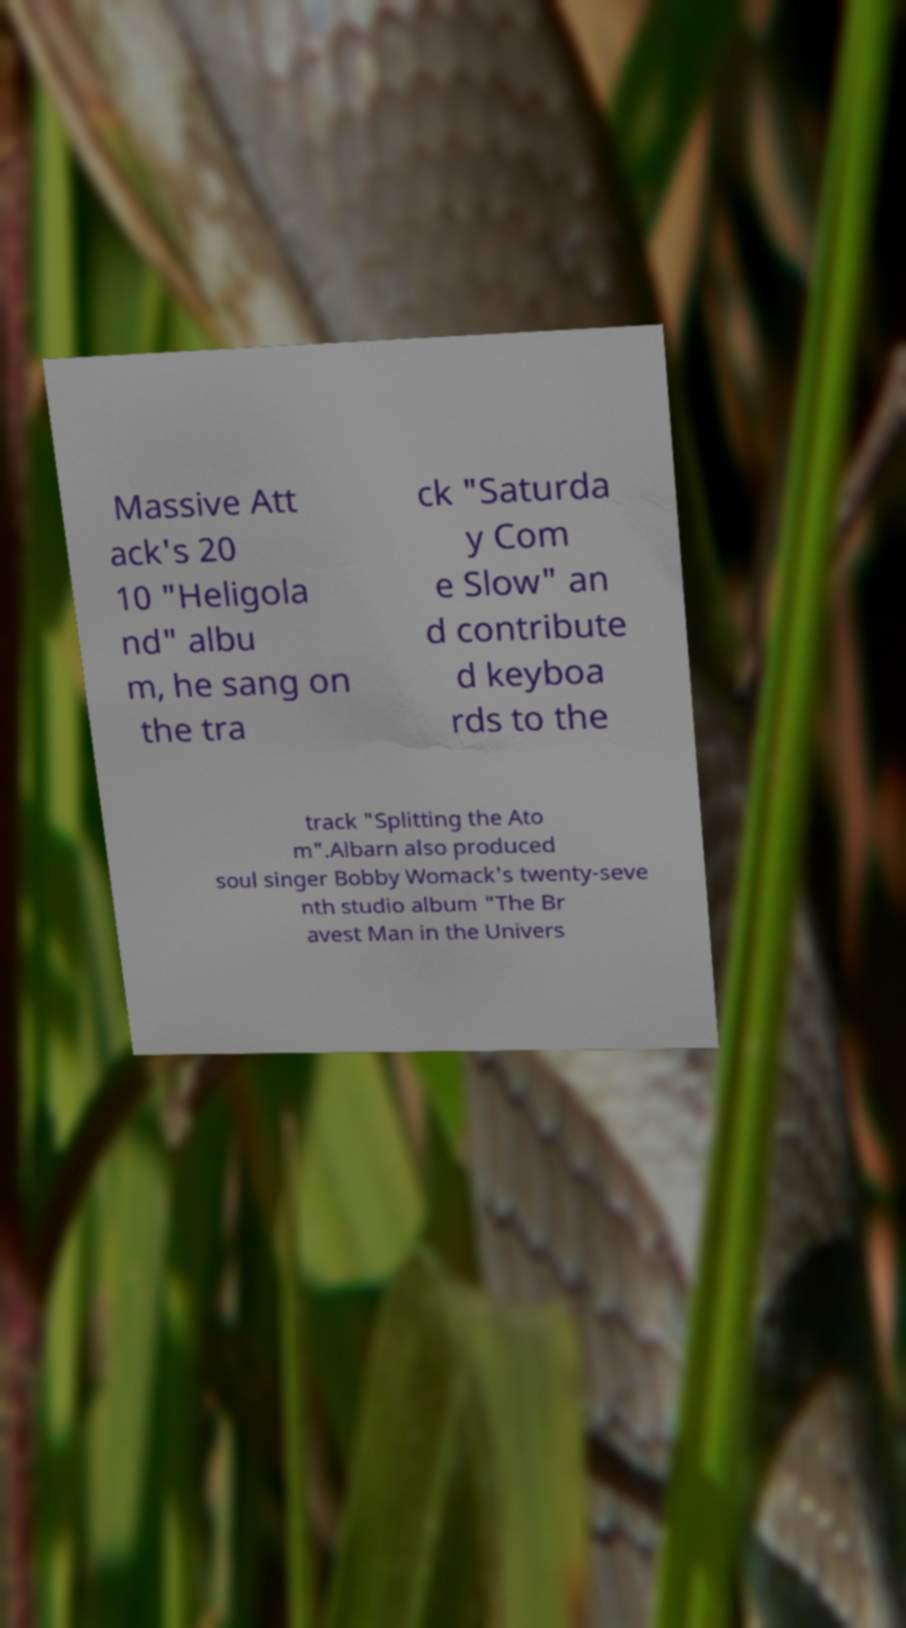Can you read and provide the text displayed in the image?This photo seems to have some interesting text. Can you extract and type it out for me? Massive Att ack's 20 10 "Heligola nd" albu m, he sang on the tra ck "Saturda y Com e Slow" an d contribute d keyboa rds to the track "Splitting the Ato m".Albarn also produced soul singer Bobby Womack's twenty-seve nth studio album "The Br avest Man in the Univers 